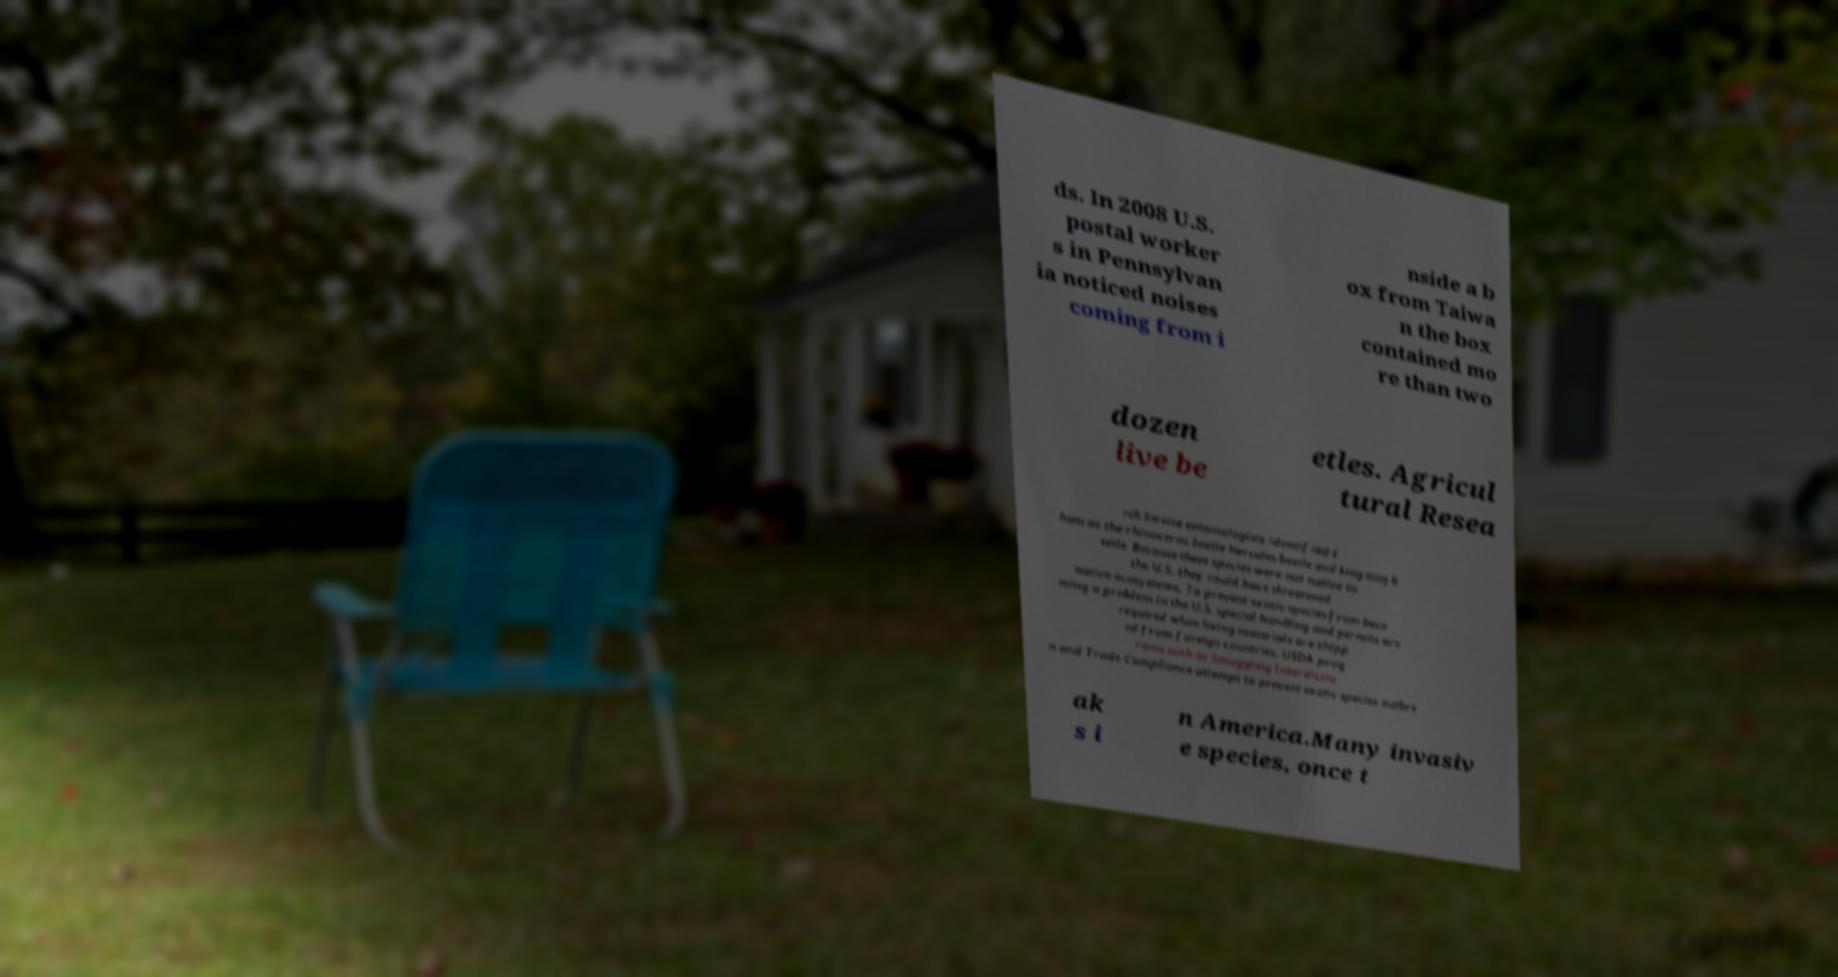Could you extract and type out the text from this image? ds. In 2008 U.S. postal worker s in Pennsylvan ia noticed noises coming from i nside a b ox from Taiwa n the box contained mo re than two dozen live be etles. Agricul tural Resea rch Service entomologists identified t hem as the rhinoceros beetle Hercules beetle and king stag b eetle. Because these species were not native to the U.S. they could have threatened native ecosystems. To prevent exotic species from beco ming a problem in the U.S. special handling and permits are required when living materials are shipp ed from foreign countries. USDA prog rams such as Smuggling Interdictio n and Trade Compliance attempt to prevent exotic species outbre ak s i n America.Many invasiv e species, once t 